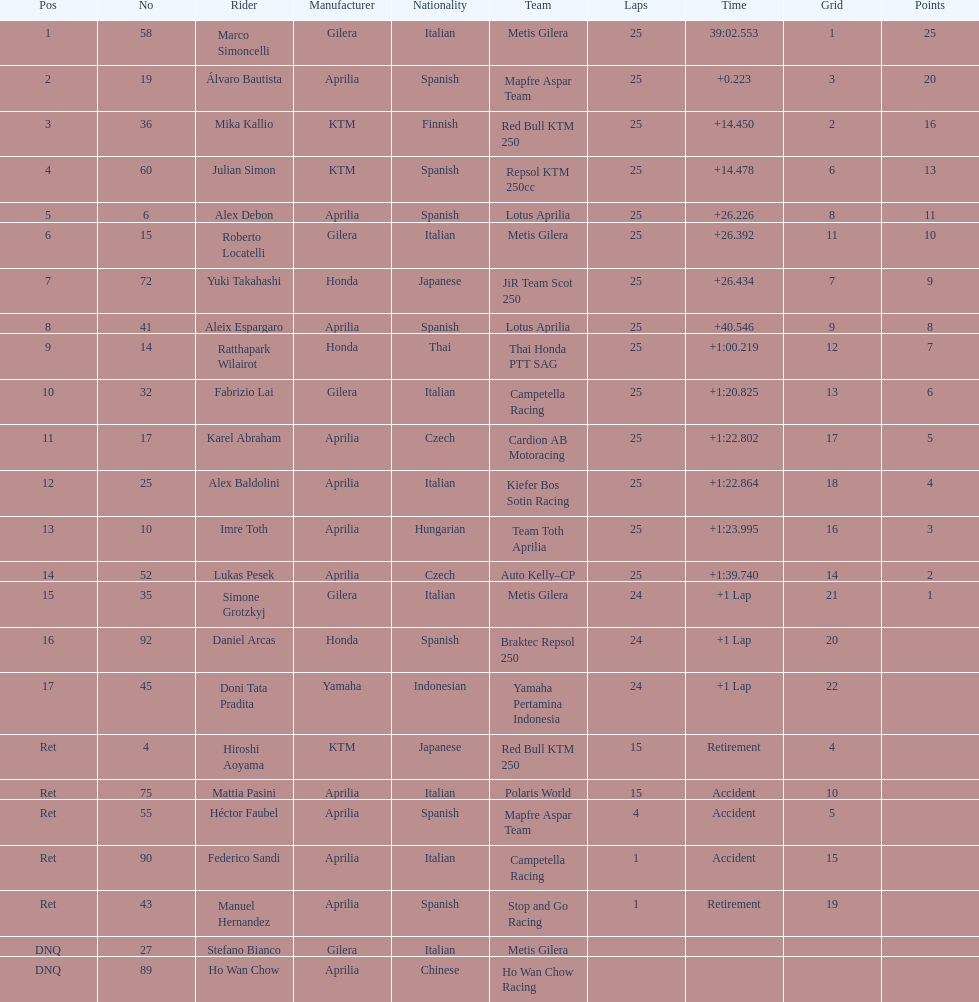Who is marco simoncelli's manufacturer Gilera. 